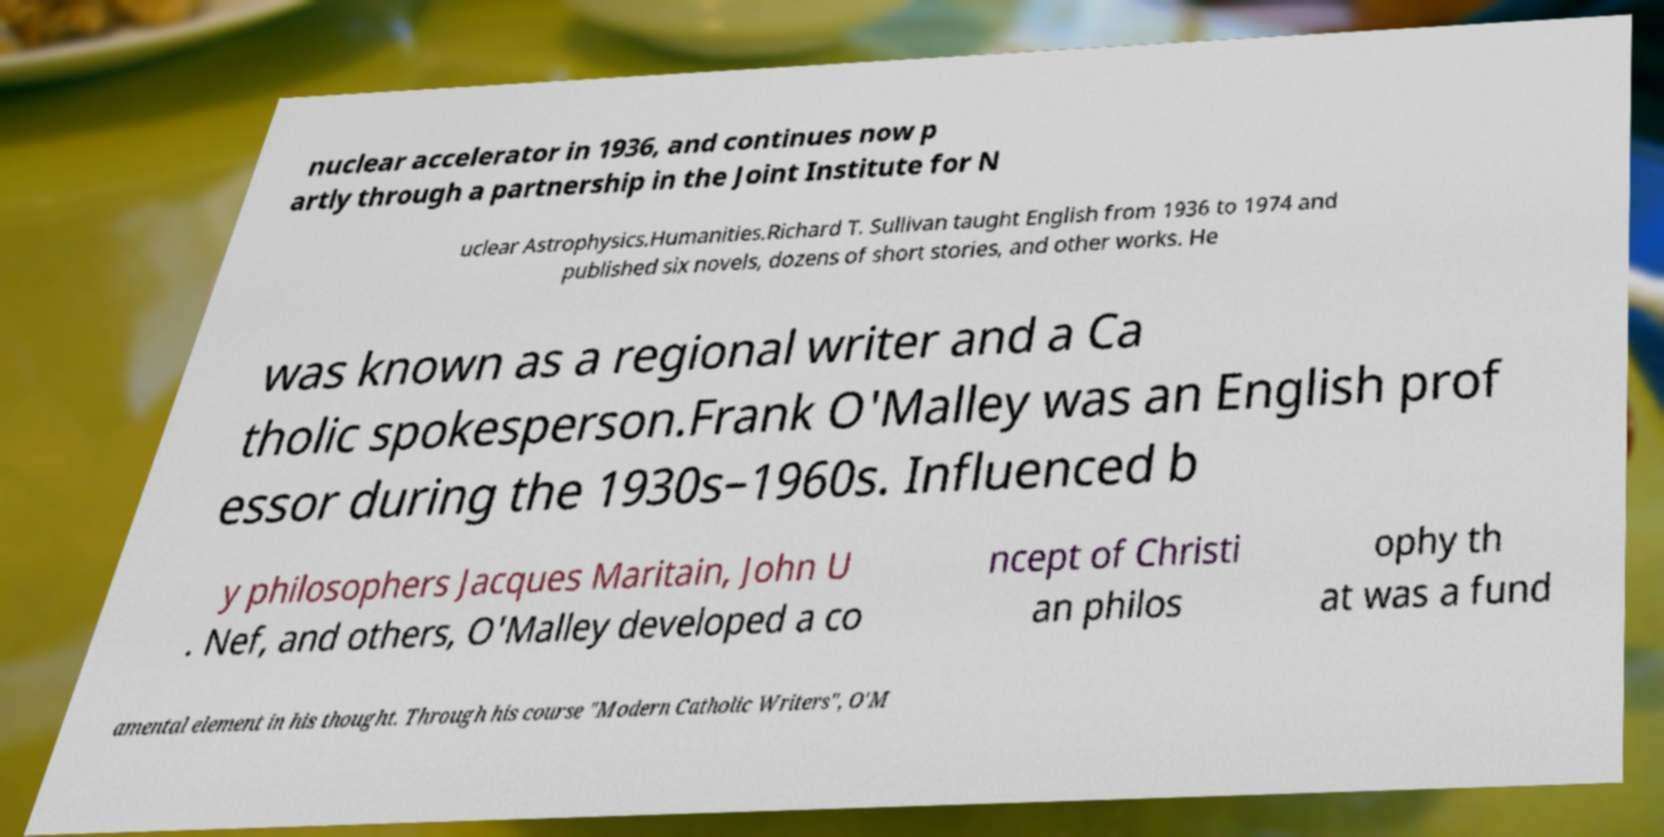Could you extract and type out the text from this image? nuclear accelerator in 1936, and continues now p artly through a partnership in the Joint Institute for N uclear Astrophysics.Humanities.Richard T. Sullivan taught English from 1936 to 1974 and published six novels, dozens of short stories, and other works. He was known as a regional writer and a Ca tholic spokesperson.Frank O'Malley was an English prof essor during the 1930s–1960s. Influenced b y philosophers Jacques Maritain, John U . Nef, and others, O'Malley developed a co ncept of Christi an philos ophy th at was a fund amental element in his thought. Through his course "Modern Catholic Writers", O'M 